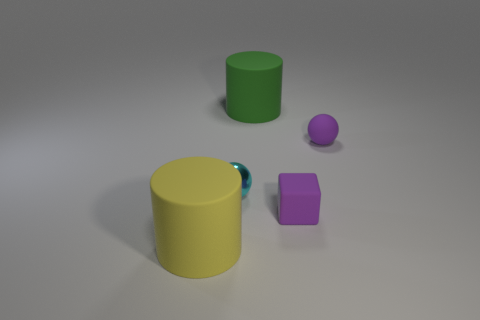What sort of textures are present on these objects? The surfaces of the objects are smooth and lack visible texture. The matte and glossy finishes give subtle clues about the tactile sensations they might provide, with the matte surfaces likely feeling less slick than the glossy ones. 